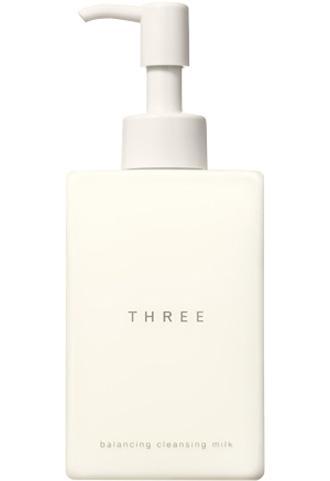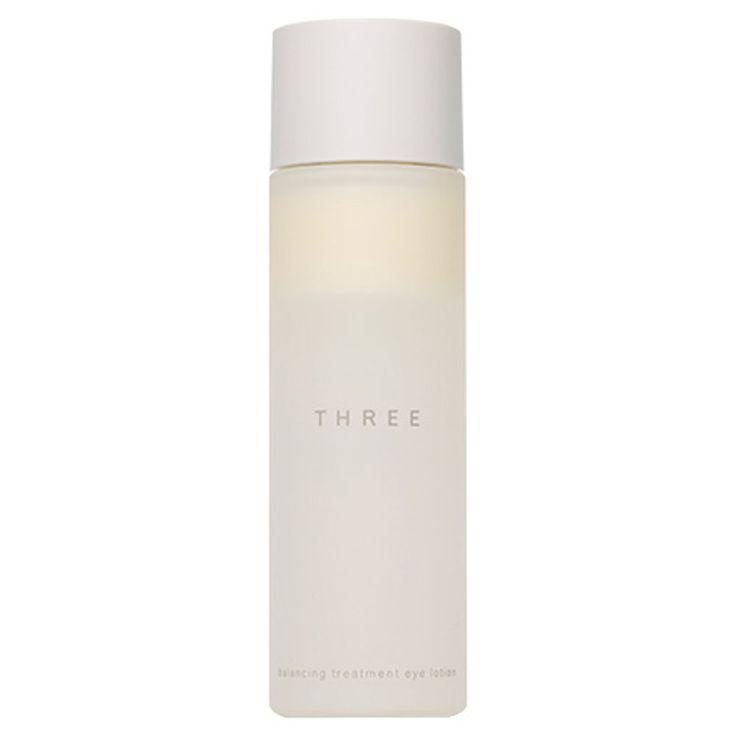The first image is the image on the left, the second image is the image on the right. Examine the images to the left and right. Is the description "One image shows an upright cylindrical bottle and the other shows a short pot-shaped product." accurate? Answer yes or no. No. The first image is the image on the left, the second image is the image on the right. Analyze the images presented: Is the assertion "Each container has a round shape." valid? Answer yes or no. No. 